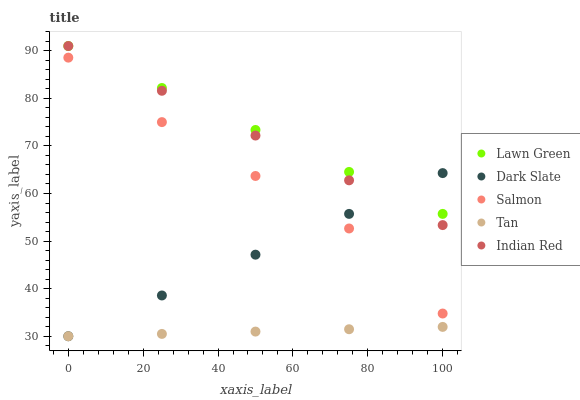Does Tan have the minimum area under the curve?
Answer yes or no. Yes. Does Lawn Green have the maximum area under the curve?
Answer yes or no. Yes. Does Salmon have the minimum area under the curve?
Answer yes or no. No. Does Salmon have the maximum area under the curve?
Answer yes or no. No. Is Dark Slate the smoothest?
Answer yes or no. Yes. Is Salmon the roughest?
Answer yes or no. Yes. Is Tan the smoothest?
Answer yes or no. No. Is Tan the roughest?
Answer yes or no. No. Does Tan have the lowest value?
Answer yes or no. Yes. Does Salmon have the lowest value?
Answer yes or no. No. Does Indian Red have the highest value?
Answer yes or no. Yes. Does Salmon have the highest value?
Answer yes or no. No. Is Salmon less than Lawn Green?
Answer yes or no. Yes. Is Salmon greater than Tan?
Answer yes or no. Yes. Does Lawn Green intersect Dark Slate?
Answer yes or no. Yes. Is Lawn Green less than Dark Slate?
Answer yes or no. No. Is Lawn Green greater than Dark Slate?
Answer yes or no. No. Does Salmon intersect Lawn Green?
Answer yes or no. No. 